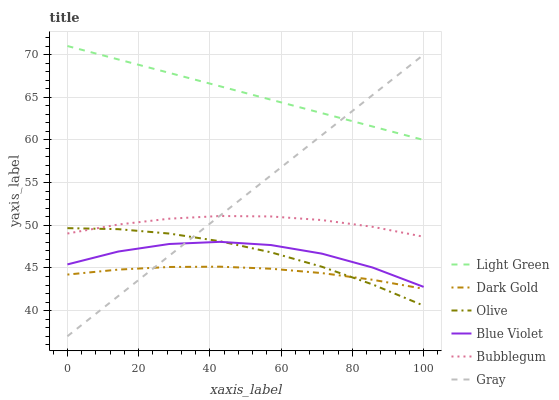Does Dark Gold have the minimum area under the curve?
Answer yes or no. Yes. Does Light Green have the maximum area under the curve?
Answer yes or no. Yes. Does Bubblegum have the minimum area under the curve?
Answer yes or no. No. Does Bubblegum have the maximum area under the curve?
Answer yes or no. No. Is Gray the smoothest?
Answer yes or no. Yes. Is Blue Violet the roughest?
Answer yes or no. Yes. Is Dark Gold the smoothest?
Answer yes or no. No. Is Dark Gold the roughest?
Answer yes or no. No. Does Gray have the lowest value?
Answer yes or no. Yes. Does Dark Gold have the lowest value?
Answer yes or no. No. Does Light Green have the highest value?
Answer yes or no. Yes. Does Bubblegum have the highest value?
Answer yes or no. No. Is Olive less than Light Green?
Answer yes or no. Yes. Is Light Green greater than Olive?
Answer yes or no. Yes. Does Gray intersect Bubblegum?
Answer yes or no. Yes. Is Gray less than Bubblegum?
Answer yes or no. No. Is Gray greater than Bubblegum?
Answer yes or no. No. Does Olive intersect Light Green?
Answer yes or no. No. 